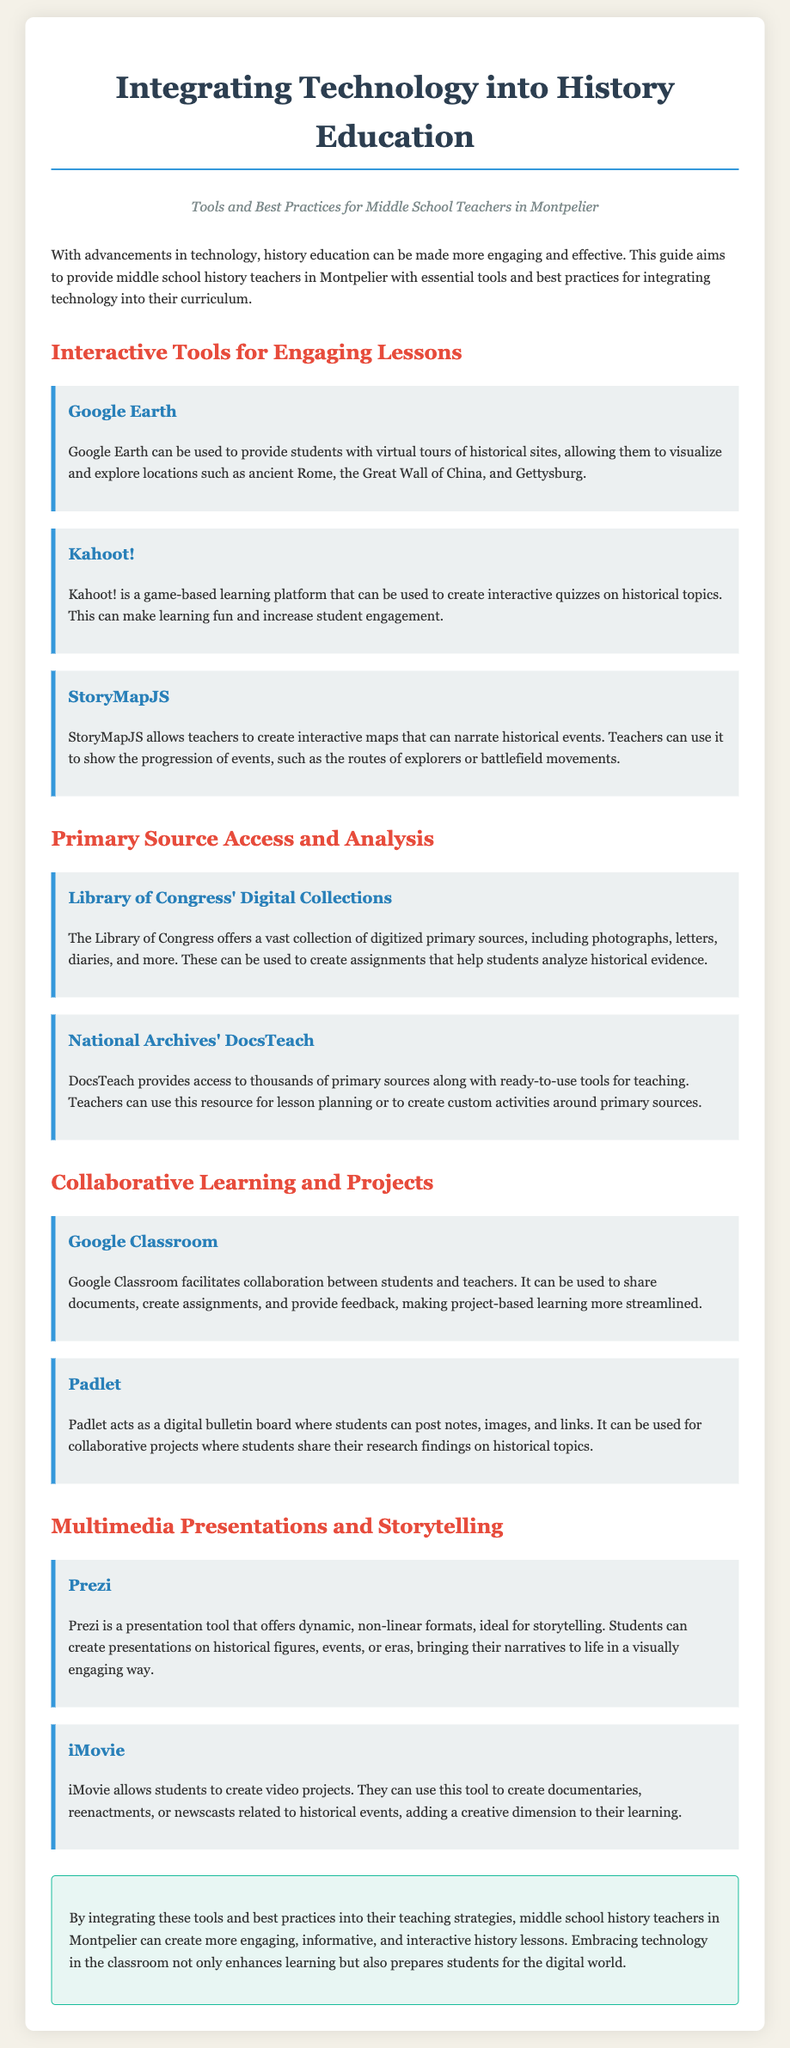What is the main focus of the guide? The main focus of the guide is to provide tools and best practices for middle school history teachers to integrate technology into their curriculum.
Answer: integrating technology into history education How many interactive tools for engaging lessons are mentioned? The document lists three interactive tools for engaging lessons.
Answer: three Which tool allows for virtual tours of historical sites? Google Earth is highlighted as the tool for virtual tours of historical sites.
Answer: Google Earth What type of projects can Google Classroom facilitate? Google Classroom facilitates collaboration for project-based learning.
Answer: collaboration What is the primary purpose of DocsTeach? DocsTeach provides access to primary sources along with tools for teaching and lesson planning.
Answer: lesson planning Which multimedia tool enables students to create documentaries? iMovie is the tool that allows students to create documentaries.
Answer: iMovie What should teachers in Montpelier do to enhance their history lessons? Teachers should integrate technology and use the recommended tools and best practices.
Answer: integrate technology What color is associated with the section headers in the document? The section headers are colored red.
Answer: red How does Padlet function in a classroom setting? Padlet acts as a digital bulletin board for collaborative projects.
Answer: digital bulletin board 